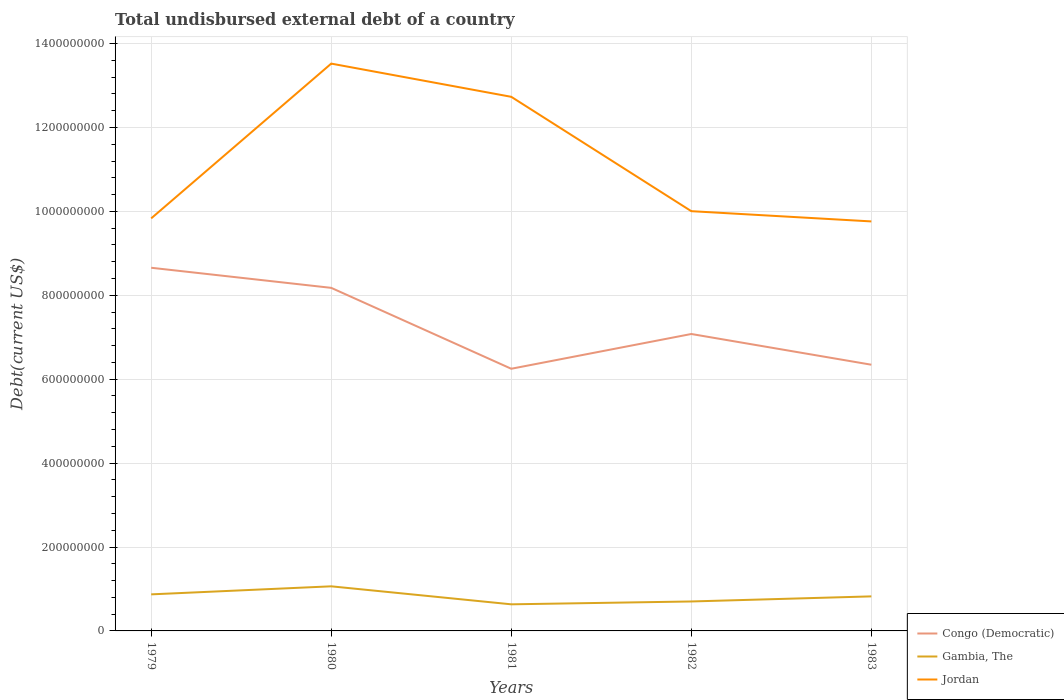Does the line corresponding to Gambia, The intersect with the line corresponding to Congo (Democratic)?
Your response must be concise. No. Is the number of lines equal to the number of legend labels?
Provide a short and direct response. Yes. Across all years, what is the maximum total undisbursed external debt in Gambia, The?
Your answer should be compact. 6.34e+07. What is the total total undisbursed external debt in Gambia, The in the graph?
Provide a short and direct response. 4.79e+06. What is the difference between the highest and the second highest total undisbursed external debt in Jordan?
Your response must be concise. 3.76e+08. How many lines are there?
Provide a short and direct response. 3. How many years are there in the graph?
Provide a succinct answer. 5. Does the graph contain any zero values?
Offer a very short reply. No. Does the graph contain grids?
Your response must be concise. Yes. Where does the legend appear in the graph?
Ensure brevity in your answer.  Bottom right. How are the legend labels stacked?
Your answer should be compact. Vertical. What is the title of the graph?
Give a very brief answer. Total undisbursed external debt of a country. What is the label or title of the Y-axis?
Ensure brevity in your answer.  Debt(current US$). What is the Debt(current US$) of Congo (Democratic) in 1979?
Make the answer very short. 8.66e+08. What is the Debt(current US$) of Gambia, The in 1979?
Offer a very short reply. 8.71e+07. What is the Debt(current US$) in Jordan in 1979?
Offer a very short reply. 9.83e+08. What is the Debt(current US$) of Congo (Democratic) in 1980?
Keep it short and to the point. 8.18e+08. What is the Debt(current US$) of Gambia, The in 1980?
Make the answer very short. 1.06e+08. What is the Debt(current US$) of Jordan in 1980?
Provide a succinct answer. 1.35e+09. What is the Debt(current US$) in Congo (Democratic) in 1981?
Make the answer very short. 6.25e+08. What is the Debt(current US$) in Gambia, The in 1981?
Offer a very short reply. 6.34e+07. What is the Debt(current US$) of Jordan in 1981?
Give a very brief answer. 1.27e+09. What is the Debt(current US$) of Congo (Democratic) in 1982?
Your answer should be compact. 7.08e+08. What is the Debt(current US$) of Gambia, The in 1982?
Your response must be concise. 7.02e+07. What is the Debt(current US$) in Jordan in 1982?
Give a very brief answer. 1.00e+09. What is the Debt(current US$) in Congo (Democratic) in 1983?
Offer a very short reply. 6.35e+08. What is the Debt(current US$) of Gambia, The in 1983?
Give a very brief answer. 8.24e+07. What is the Debt(current US$) in Jordan in 1983?
Your answer should be very brief. 9.76e+08. Across all years, what is the maximum Debt(current US$) of Congo (Democratic)?
Provide a short and direct response. 8.66e+08. Across all years, what is the maximum Debt(current US$) of Gambia, The?
Offer a very short reply. 1.06e+08. Across all years, what is the maximum Debt(current US$) of Jordan?
Provide a succinct answer. 1.35e+09. Across all years, what is the minimum Debt(current US$) of Congo (Democratic)?
Provide a succinct answer. 6.25e+08. Across all years, what is the minimum Debt(current US$) in Gambia, The?
Make the answer very short. 6.34e+07. Across all years, what is the minimum Debt(current US$) of Jordan?
Make the answer very short. 9.76e+08. What is the total Debt(current US$) of Congo (Democratic) in the graph?
Keep it short and to the point. 3.65e+09. What is the total Debt(current US$) of Gambia, The in the graph?
Keep it short and to the point. 4.09e+08. What is the total Debt(current US$) of Jordan in the graph?
Your response must be concise. 5.59e+09. What is the difference between the Debt(current US$) of Congo (Democratic) in 1979 and that in 1980?
Make the answer very short. 4.79e+07. What is the difference between the Debt(current US$) in Gambia, The in 1979 and that in 1980?
Your answer should be compact. -1.92e+07. What is the difference between the Debt(current US$) of Jordan in 1979 and that in 1980?
Your answer should be compact. -3.69e+08. What is the difference between the Debt(current US$) of Congo (Democratic) in 1979 and that in 1981?
Your answer should be very brief. 2.41e+08. What is the difference between the Debt(current US$) of Gambia, The in 1979 and that in 1981?
Give a very brief answer. 2.37e+07. What is the difference between the Debt(current US$) in Jordan in 1979 and that in 1981?
Ensure brevity in your answer.  -2.90e+08. What is the difference between the Debt(current US$) in Congo (Democratic) in 1979 and that in 1982?
Offer a very short reply. 1.58e+08. What is the difference between the Debt(current US$) of Gambia, The in 1979 and that in 1982?
Your answer should be compact. 1.70e+07. What is the difference between the Debt(current US$) of Jordan in 1979 and that in 1982?
Ensure brevity in your answer.  -1.72e+07. What is the difference between the Debt(current US$) in Congo (Democratic) in 1979 and that in 1983?
Offer a terse response. 2.31e+08. What is the difference between the Debt(current US$) of Gambia, The in 1979 and that in 1983?
Give a very brief answer. 4.79e+06. What is the difference between the Debt(current US$) of Jordan in 1979 and that in 1983?
Ensure brevity in your answer.  7.24e+06. What is the difference between the Debt(current US$) of Congo (Democratic) in 1980 and that in 1981?
Your response must be concise. 1.93e+08. What is the difference between the Debt(current US$) of Gambia, The in 1980 and that in 1981?
Your answer should be very brief. 4.29e+07. What is the difference between the Debt(current US$) of Jordan in 1980 and that in 1981?
Make the answer very short. 7.92e+07. What is the difference between the Debt(current US$) of Congo (Democratic) in 1980 and that in 1982?
Keep it short and to the point. 1.10e+08. What is the difference between the Debt(current US$) in Gambia, The in 1980 and that in 1982?
Keep it short and to the point. 3.61e+07. What is the difference between the Debt(current US$) of Jordan in 1980 and that in 1982?
Your response must be concise. 3.52e+08. What is the difference between the Debt(current US$) of Congo (Democratic) in 1980 and that in 1983?
Your answer should be compact. 1.83e+08. What is the difference between the Debt(current US$) of Gambia, The in 1980 and that in 1983?
Your answer should be very brief. 2.40e+07. What is the difference between the Debt(current US$) of Jordan in 1980 and that in 1983?
Give a very brief answer. 3.76e+08. What is the difference between the Debt(current US$) in Congo (Democratic) in 1981 and that in 1982?
Offer a terse response. -8.29e+07. What is the difference between the Debt(current US$) of Gambia, The in 1981 and that in 1982?
Provide a short and direct response. -6.78e+06. What is the difference between the Debt(current US$) in Jordan in 1981 and that in 1982?
Ensure brevity in your answer.  2.73e+08. What is the difference between the Debt(current US$) of Congo (Democratic) in 1981 and that in 1983?
Provide a succinct answer. -9.63e+06. What is the difference between the Debt(current US$) in Gambia, The in 1981 and that in 1983?
Your answer should be compact. -1.90e+07. What is the difference between the Debt(current US$) of Jordan in 1981 and that in 1983?
Offer a terse response. 2.97e+08. What is the difference between the Debt(current US$) in Congo (Democratic) in 1982 and that in 1983?
Your response must be concise. 7.32e+07. What is the difference between the Debt(current US$) in Gambia, The in 1982 and that in 1983?
Keep it short and to the point. -1.22e+07. What is the difference between the Debt(current US$) in Jordan in 1982 and that in 1983?
Your answer should be very brief. 2.44e+07. What is the difference between the Debt(current US$) of Congo (Democratic) in 1979 and the Debt(current US$) of Gambia, The in 1980?
Offer a terse response. 7.59e+08. What is the difference between the Debt(current US$) of Congo (Democratic) in 1979 and the Debt(current US$) of Jordan in 1980?
Your answer should be compact. -4.87e+08. What is the difference between the Debt(current US$) in Gambia, The in 1979 and the Debt(current US$) in Jordan in 1980?
Your response must be concise. -1.27e+09. What is the difference between the Debt(current US$) of Congo (Democratic) in 1979 and the Debt(current US$) of Gambia, The in 1981?
Your answer should be compact. 8.02e+08. What is the difference between the Debt(current US$) in Congo (Democratic) in 1979 and the Debt(current US$) in Jordan in 1981?
Give a very brief answer. -4.07e+08. What is the difference between the Debt(current US$) of Gambia, The in 1979 and the Debt(current US$) of Jordan in 1981?
Give a very brief answer. -1.19e+09. What is the difference between the Debt(current US$) of Congo (Democratic) in 1979 and the Debt(current US$) of Gambia, The in 1982?
Offer a very short reply. 7.95e+08. What is the difference between the Debt(current US$) of Congo (Democratic) in 1979 and the Debt(current US$) of Jordan in 1982?
Offer a very short reply. -1.35e+08. What is the difference between the Debt(current US$) of Gambia, The in 1979 and the Debt(current US$) of Jordan in 1982?
Ensure brevity in your answer.  -9.13e+08. What is the difference between the Debt(current US$) in Congo (Democratic) in 1979 and the Debt(current US$) in Gambia, The in 1983?
Give a very brief answer. 7.83e+08. What is the difference between the Debt(current US$) in Congo (Democratic) in 1979 and the Debt(current US$) in Jordan in 1983?
Offer a very short reply. -1.10e+08. What is the difference between the Debt(current US$) of Gambia, The in 1979 and the Debt(current US$) of Jordan in 1983?
Provide a short and direct response. -8.89e+08. What is the difference between the Debt(current US$) of Congo (Democratic) in 1980 and the Debt(current US$) of Gambia, The in 1981?
Offer a terse response. 7.54e+08. What is the difference between the Debt(current US$) of Congo (Democratic) in 1980 and the Debt(current US$) of Jordan in 1981?
Keep it short and to the point. -4.55e+08. What is the difference between the Debt(current US$) of Gambia, The in 1980 and the Debt(current US$) of Jordan in 1981?
Offer a terse response. -1.17e+09. What is the difference between the Debt(current US$) in Congo (Democratic) in 1980 and the Debt(current US$) in Gambia, The in 1982?
Your answer should be compact. 7.48e+08. What is the difference between the Debt(current US$) in Congo (Democratic) in 1980 and the Debt(current US$) in Jordan in 1982?
Your response must be concise. -1.83e+08. What is the difference between the Debt(current US$) of Gambia, The in 1980 and the Debt(current US$) of Jordan in 1982?
Give a very brief answer. -8.94e+08. What is the difference between the Debt(current US$) in Congo (Democratic) in 1980 and the Debt(current US$) in Gambia, The in 1983?
Offer a very short reply. 7.35e+08. What is the difference between the Debt(current US$) of Congo (Democratic) in 1980 and the Debt(current US$) of Jordan in 1983?
Your response must be concise. -1.58e+08. What is the difference between the Debt(current US$) in Gambia, The in 1980 and the Debt(current US$) in Jordan in 1983?
Give a very brief answer. -8.70e+08. What is the difference between the Debt(current US$) in Congo (Democratic) in 1981 and the Debt(current US$) in Gambia, The in 1982?
Offer a very short reply. 5.55e+08. What is the difference between the Debt(current US$) of Congo (Democratic) in 1981 and the Debt(current US$) of Jordan in 1982?
Your response must be concise. -3.76e+08. What is the difference between the Debt(current US$) in Gambia, The in 1981 and the Debt(current US$) in Jordan in 1982?
Offer a terse response. -9.37e+08. What is the difference between the Debt(current US$) of Congo (Democratic) in 1981 and the Debt(current US$) of Gambia, The in 1983?
Provide a short and direct response. 5.43e+08. What is the difference between the Debt(current US$) in Congo (Democratic) in 1981 and the Debt(current US$) in Jordan in 1983?
Your response must be concise. -3.51e+08. What is the difference between the Debt(current US$) of Gambia, The in 1981 and the Debt(current US$) of Jordan in 1983?
Offer a terse response. -9.13e+08. What is the difference between the Debt(current US$) of Congo (Democratic) in 1982 and the Debt(current US$) of Gambia, The in 1983?
Keep it short and to the point. 6.25e+08. What is the difference between the Debt(current US$) in Congo (Democratic) in 1982 and the Debt(current US$) in Jordan in 1983?
Provide a succinct answer. -2.68e+08. What is the difference between the Debt(current US$) in Gambia, The in 1982 and the Debt(current US$) in Jordan in 1983?
Offer a terse response. -9.06e+08. What is the average Debt(current US$) in Congo (Democratic) per year?
Your answer should be compact. 7.30e+08. What is the average Debt(current US$) of Gambia, The per year?
Keep it short and to the point. 8.19e+07. What is the average Debt(current US$) in Jordan per year?
Make the answer very short. 1.12e+09. In the year 1979, what is the difference between the Debt(current US$) in Congo (Democratic) and Debt(current US$) in Gambia, The?
Provide a short and direct response. 7.78e+08. In the year 1979, what is the difference between the Debt(current US$) of Congo (Democratic) and Debt(current US$) of Jordan?
Provide a succinct answer. -1.18e+08. In the year 1979, what is the difference between the Debt(current US$) in Gambia, The and Debt(current US$) in Jordan?
Your answer should be very brief. -8.96e+08. In the year 1980, what is the difference between the Debt(current US$) of Congo (Democratic) and Debt(current US$) of Gambia, The?
Make the answer very short. 7.11e+08. In the year 1980, what is the difference between the Debt(current US$) of Congo (Democratic) and Debt(current US$) of Jordan?
Give a very brief answer. -5.34e+08. In the year 1980, what is the difference between the Debt(current US$) in Gambia, The and Debt(current US$) in Jordan?
Keep it short and to the point. -1.25e+09. In the year 1981, what is the difference between the Debt(current US$) of Congo (Democratic) and Debt(current US$) of Gambia, The?
Your answer should be compact. 5.61e+08. In the year 1981, what is the difference between the Debt(current US$) in Congo (Democratic) and Debt(current US$) in Jordan?
Give a very brief answer. -6.48e+08. In the year 1981, what is the difference between the Debt(current US$) of Gambia, The and Debt(current US$) of Jordan?
Give a very brief answer. -1.21e+09. In the year 1982, what is the difference between the Debt(current US$) in Congo (Democratic) and Debt(current US$) in Gambia, The?
Give a very brief answer. 6.38e+08. In the year 1982, what is the difference between the Debt(current US$) in Congo (Democratic) and Debt(current US$) in Jordan?
Keep it short and to the point. -2.93e+08. In the year 1982, what is the difference between the Debt(current US$) of Gambia, The and Debt(current US$) of Jordan?
Give a very brief answer. -9.30e+08. In the year 1983, what is the difference between the Debt(current US$) in Congo (Democratic) and Debt(current US$) in Gambia, The?
Ensure brevity in your answer.  5.52e+08. In the year 1983, what is the difference between the Debt(current US$) in Congo (Democratic) and Debt(current US$) in Jordan?
Give a very brief answer. -3.42e+08. In the year 1983, what is the difference between the Debt(current US$) in Gambia, The and Debt(current US$) in Jordan?
Your answer should be compact. -8.94e+08. What is the ratio of the Debt(current US$) in Congo (Democratic) in 1979 to that in 1980?
Give a very brief answer. 1.06. What is the ratio of the Debt(current US$) of Gambia, The in 1979 to that in 1980?
Offer a terse response. 0.82. What is the ratio of the Debt(current US$) in Jordan in 1979 to that in 1980?
Offer a terse response. 0.73. What is the ratio of the Debt(current US$) in Congo (Democratic) in 1979 to that in 1981?
Offer a very short reply. 1.39. What is the ratio of the Debt(current US$) of Gambia, The in 1979 to that in 1981?
Make the answer very short. 1.37. What is the ratio of the Debt(current US$) of Jordan in 1979 to that in 1981?
Your answer should be very brief. 0.77. What is the ratio of the Debt(current US$) of Congo (Democratic) in 1979 to that in 1982?
Offer a terse response. 1.22. What is the ratio of the Debt(current US$) of Gambia, The in 1979 to that in 1982?
Provide a short and direct response. 1.24. What is the ratio of the Debt(current US$) of Jordan in 1979 to that in 1982?
Your answer should be compact. 0.98. What is the ratio of the Debt(current US$) of Congo (Democratic) in 1979 to that in 1983?
Provide a succinct answer. 1.36. What is the ratio of the Debt(current US$) of Gambia, The in 1979 to that in 1983?
Keep it short and to the point. 1.06. What is the ratio of the Debt(current US$) of Jordan in 1979 to that in 1983?
Offer a very short reply. 1.01. What is the ratio of the Debt(current US$) of Congo (Democratic) in 1980 to that in 1981?
Make the answer very short. 1.31. What is the ratio of the Debt(current US$) of Gambia, The in 1980 to that in 1981?
Offer a terse response. 1.68. What is the ratio of the Debt(current US$) of Jordan in 1980 to that in 1981?
Your response must be concise. 1.06. What is the ratio of the Debt(current US$) in Congo (Democratic) in 1980 to that in 1982?
Your answer should be very brief. 1.16. What is the ratio of the Debt(current US$) of Gambia, The in 1980 to that in 1982?
Offer a terse response. 1.51. What is the ratio of the Debt(current US$) of Jordan in 1980 to that in 1982?
Give a very brief answer. 1.35. What is the ratio of the Debt(current US$) of Congo (Democratic) in 1980 to that in 1983?
Your answer should be very brief. 1.29. What is the ratio of the Debt(current US$) in Gambia, The in 1980 to that in 1983?
Your response must be concise. 1.29. What is the ratio of the Debt(current US$) in Jordan in 1980 to that in 1983?
Provide a succinct answer. 1.39. What is the ratio of the Debt(current US$) of Congo (Democratic) in 1981 to that in 1982?
Keep it short and to the point. 0.88. What is the ratio of the Debt(current US$) of Gambia, The in 1981 to that in 1982?
Provide a short and direct response. 0.9. What is the ratio of the Debt(current US$) in Jordan in 1981 to that in 1982?
Provide a succinct answer. 1.27. What is the ratio of the Debt(current US$) in Congo (Democratic) in 1981 to that in 1983?
Offer a terse response. 0.98. What is the ratio of the Debt(current US$) in Gambia, The in 1981 to that in 1983?
Give a very brief answer. 0.77. What is the ratio of the Debt(current US$) of Jordan in 1981 to that in 1983?
Provide a short and direct response. 1.3. What is the ratio of the Debt(current US$) in Congo (Democratic) in 1982 to that in 1983?
Offer a very short reply. 1.12. What is the ratio of the Debt(current US$) in Gambia, The in 1982 to that in 1983?
Make the answer very short. 0.85. What is the ratio of the Debt(current US$) in Jordan in 1982 to that in 1983?
Give a very brief answer. 1.02. What is the difference between the highest and the second highest Debt(current US$) of Congo (Democratic)?
Provide a succinct answer. 4.79e+07. What is the difference between the highest and the second highest Debt(current US$) of Gambia, The?
Provide a succinct answer. 1.92e+07. What is the difference between the highest and the second highest Debt(current US$) in Jordan?
Offer a very short reply. 7.92e+07. What is the difference between the highest and the lowest Debt(current US$) in Congo (Democratic)?
Keep it short and to the point. 2.41e+08. What is the difference between the highest and the lowest Debt(current US$) in Gambia, The?
Make the answer very short. 4.29e+07. What is the difference between the highest and the lowest Debt(current US$) of Jordan?
Your answer should be compact. 3.76e+08. 